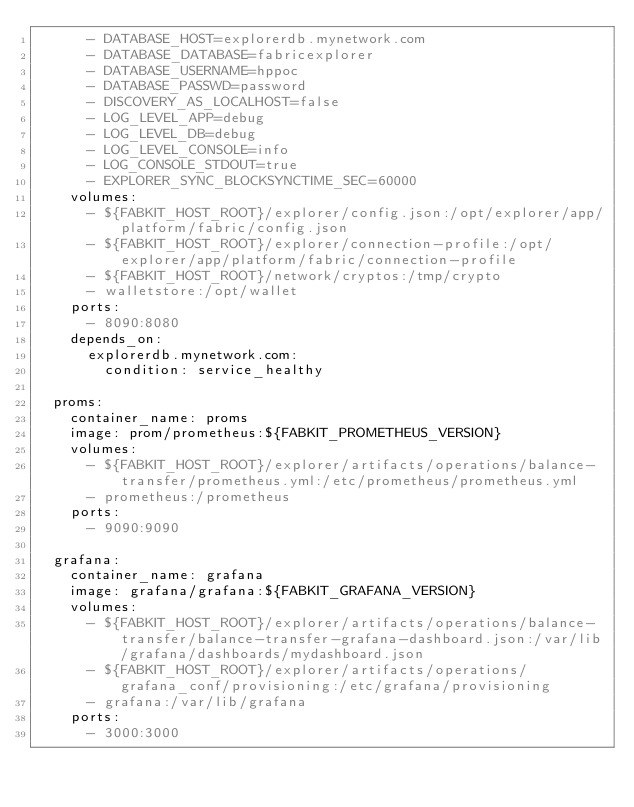<code> <loc_0><loc_0><loc_500><loc_500><_YAML_>      - DATABASE_HOST=explorerdb.mynetwork.com
      - DATABASE_DATABASE=fabricexplorer
      - DATABASE_USERNAME=hppoc
      - DATABASE_PASSWD=password
      - DISCOVERY_AS_LOCALHOST=false
      - LOG_LEVEL_APP=debug
      - LOG_LEVEL_DB=debug
      - LOG_LEVEL_CONSOLE=info
      - LOG_CONSOLE_STDOUT=true
      - EXPLORER_SYNC_BLOCKSYNCTIME_SEC=60000
    volumes:
      - ${FABKIT_HOST_ROOT}/explorer/config.json:/opt/explorer/app/platform/fabric/config.json
      - ${FABKIT_HOST_ROOT}/explorer/connection-profile:/opt/explorer/app/platform/fabric/connection-profile
      - ${FABKIT_HOST_ROOT}/network/cryptos:/tmp/crypto
      - walletstore:/opt/wallet
    ports:
      - 8090:8080
    depends_on:
      explorerdb.mynetwork.com:
        condition: service_healthy

  proms:
    container_name: proms
    image: prom/prometheus:${FABKIT_PROMETHEUS_VERSION}
    volumes:
      - ${FABKIT_HOST_ROOT}/explorer/artifacts/operations/balance-transfer/prometheus.yml:/etc/prometheus/prometheus.yml
      - prometheus:/prometheus
    ports:
      - 9090:9090

  grafana:
    container_name: grafana
    image: grafana/grafana:${FABKIT_GRAFANA_VERSION}
    volumes:
      - ${FABKIT_HOST_ROOT}/explorer/artifacts/operations/balance-transfer/balance-transfer-grafana-dashboard.json:/var/lib/grafana/dashboards/mydashboard.json
      - ${FABKIT_HOST_ROOT}/explorer/artifacts/operations/grafana_conf/provisioning:/etc/grafana/provisioning
      - grafana:/var/lib/grafana
    ports:
      - 3000:3000
</code> 